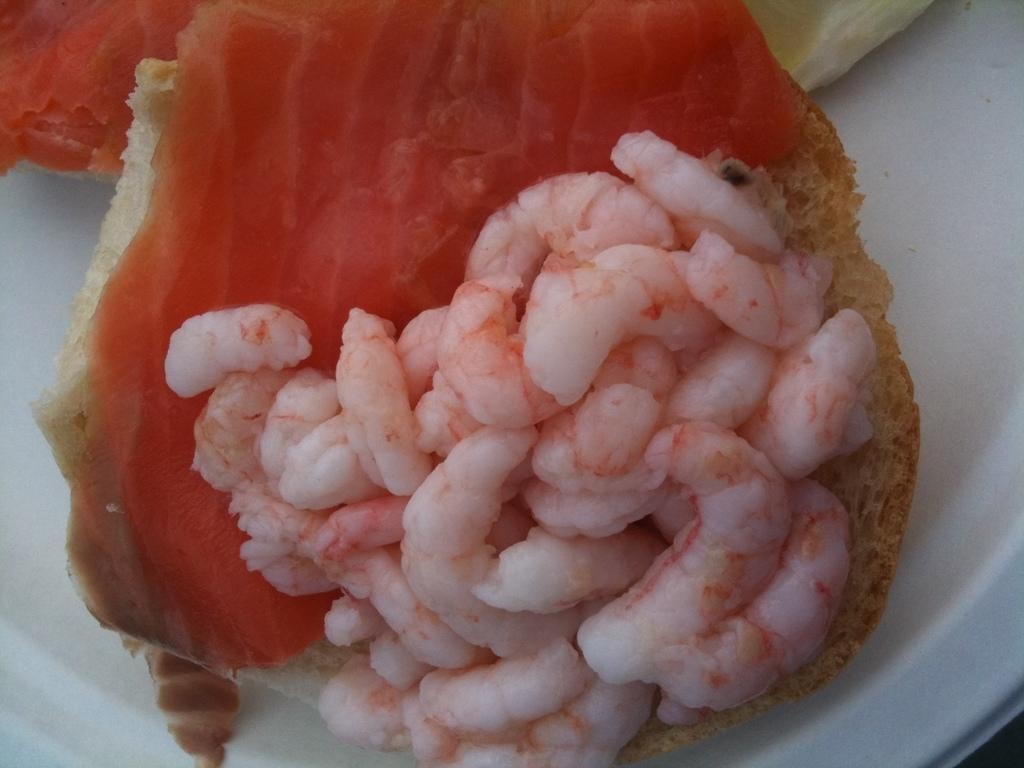What type of objects can be seen in the image? There are food items in the image. What is the color of the object on which the food items are placed? The food items are on a white object. Can you see the tail of the animal in the image? There is no animal or tail present in the image; it only contains food items on a white object. 